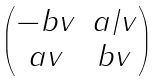<formula> <loc_0><loc_0><loc_500><loc_500>\begin{pmatrix} - b v & a / v \\ a v & b v \end{pmatrix}</formula> 